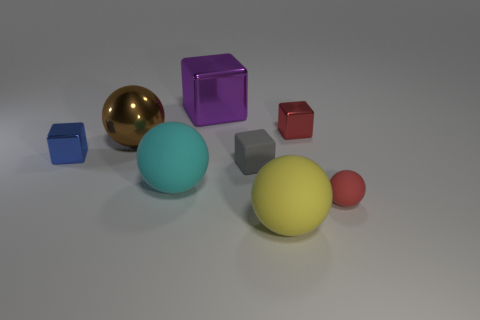Subtract all blue cubes. How many cubes are left? 3 Subtract all purple cylinders. How many cyan blocks are left? 0 Subtract all brown spheres. How many spheres are left? 3 Subtract 1 spheres. How many spheres are left? 3 Subtract all purple cubes. Subtract all purple balls. How many cubes are left? 3 Subtract all red metallic cubes. Subtract all big cyan rubber objects. How many objects are left? 6 Add 3 blue objects. How many blue objects are left? 4 Add 5 brown metal spheres. How many brown metal spheres exist? 6 Add 1 red shiny objects. How many objects exist? 9 Subtract 0 purple spheres. How many objects are left? 8 